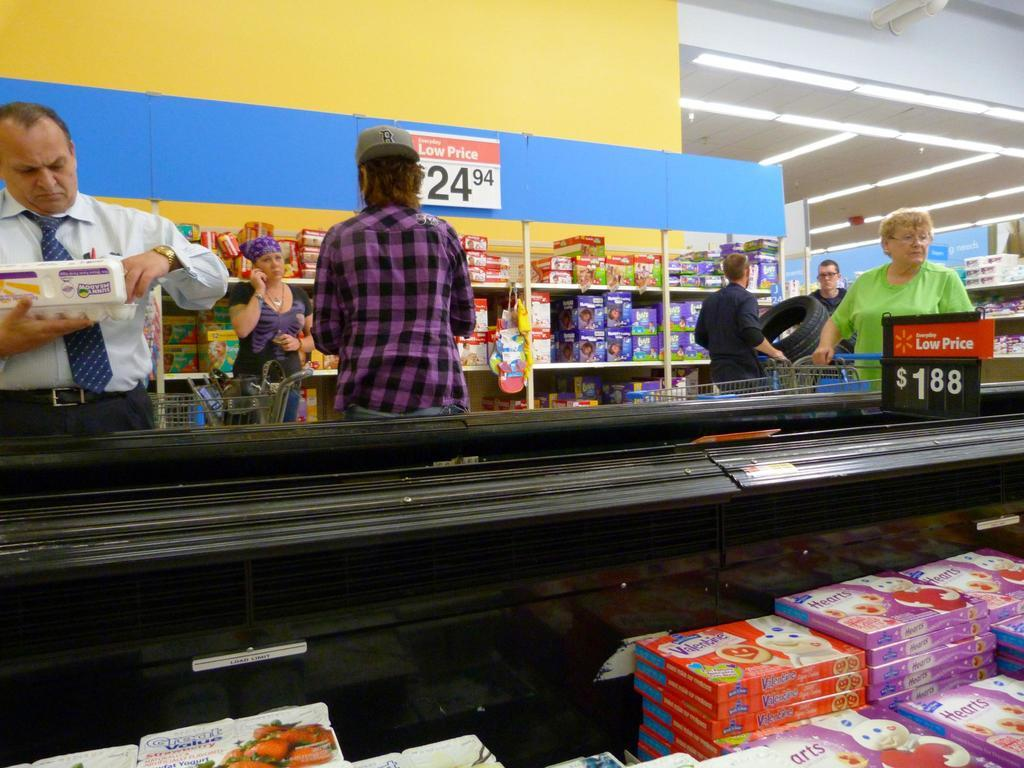<image>
Create a compact narrative representing the image presented. A grocery case with sugar cookie dough in it with one being Hearts. 